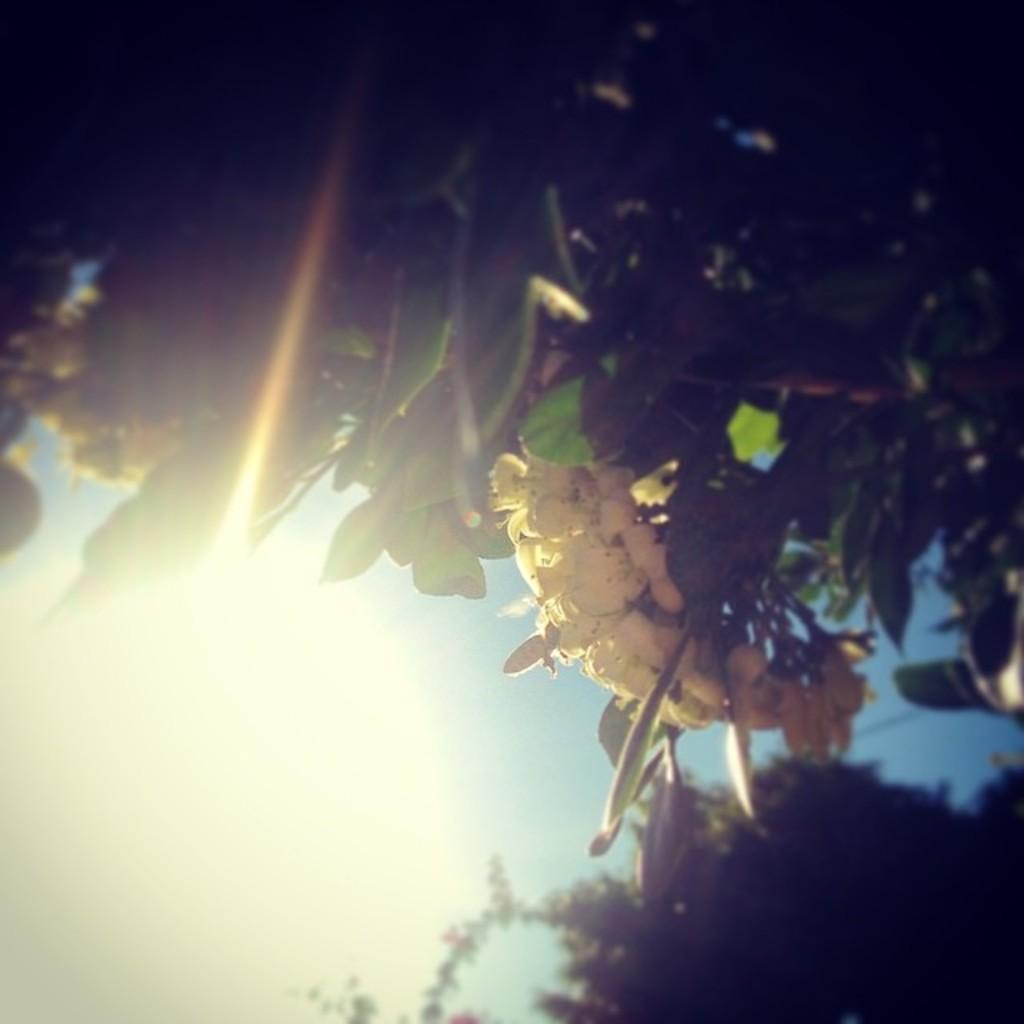What type of living organisms can be seen in the image? Plants can be seen in the image. What specific feature of the plants is visible? The plants have flowers. What color are the flowers? The flowers are cream in color. What can be seen in the background of the image? There is a sky visible in the background of the image. What is the weather like in the image? Sunshine is present in the image, suggesting a sunny day. How many pizzas are being served on the table in the image? There is no table or pizzas present in the image; it features plants with flowers and a sky background. What type of cup is being used to water the plants in the image? There is no cup or watering activity depicted in the image; it only shows plants with flowers and a sky background. 